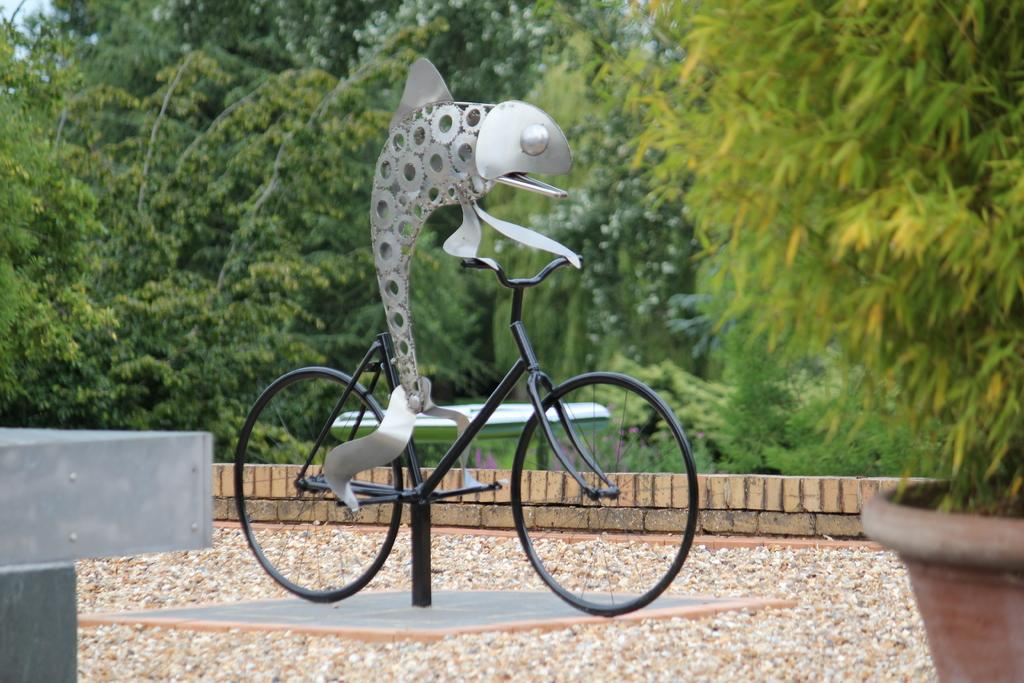What is the main subject of the image? The main subject of the image is a fish. What is the fish doing in the image? The fish is on a cycle and has its feet on the paddle. What can be seen on the right side of the image? There is a plant on the right side of the image. What is visible in the background of the image? There are trees in the background of the image. What type of record is being played in the image? There is no record or any indication of music playing in the image; it features a fish on a cycle with its feet on the paddle. 